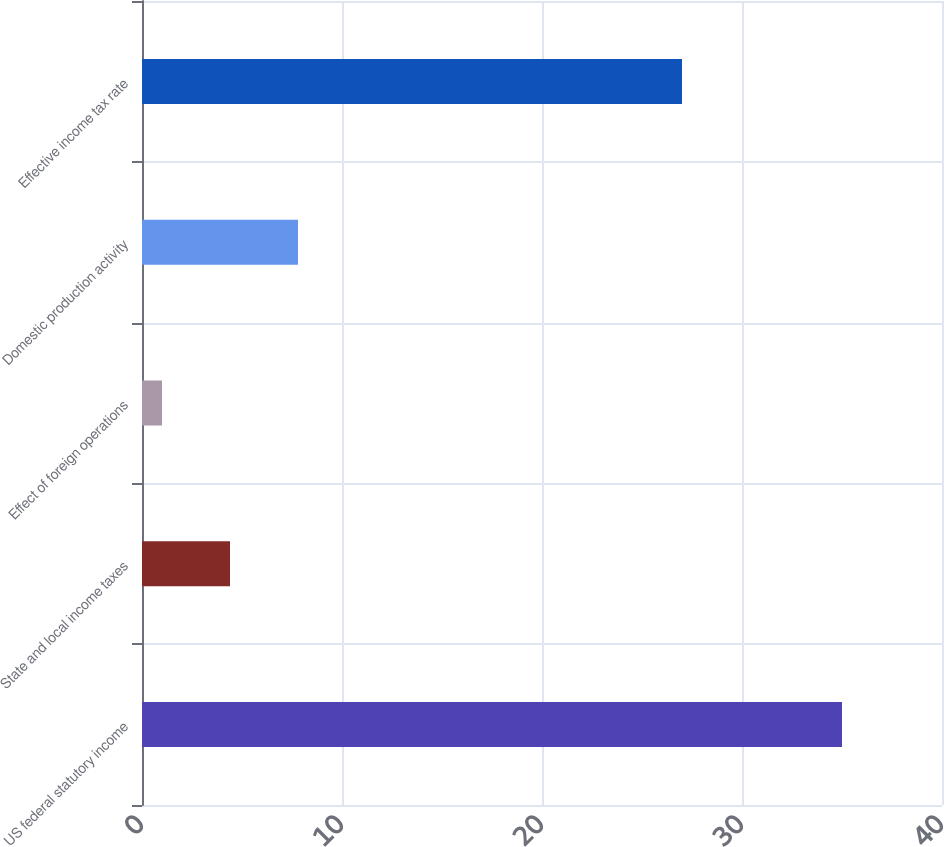Convert chart to OTSL. <chart><loc_0><loc_0><loc_500><loc_500><bar_chart><fcel>US federal statutory income<fcel>State and local income taxes<fcel>Effect of foreign operations<fcel>Domestic production activity<fcel>Effective income tax rate<nl><fcel>35<fcel>4.4<fcel>1<fcel>7.8<fcel>27<nl></chart> 